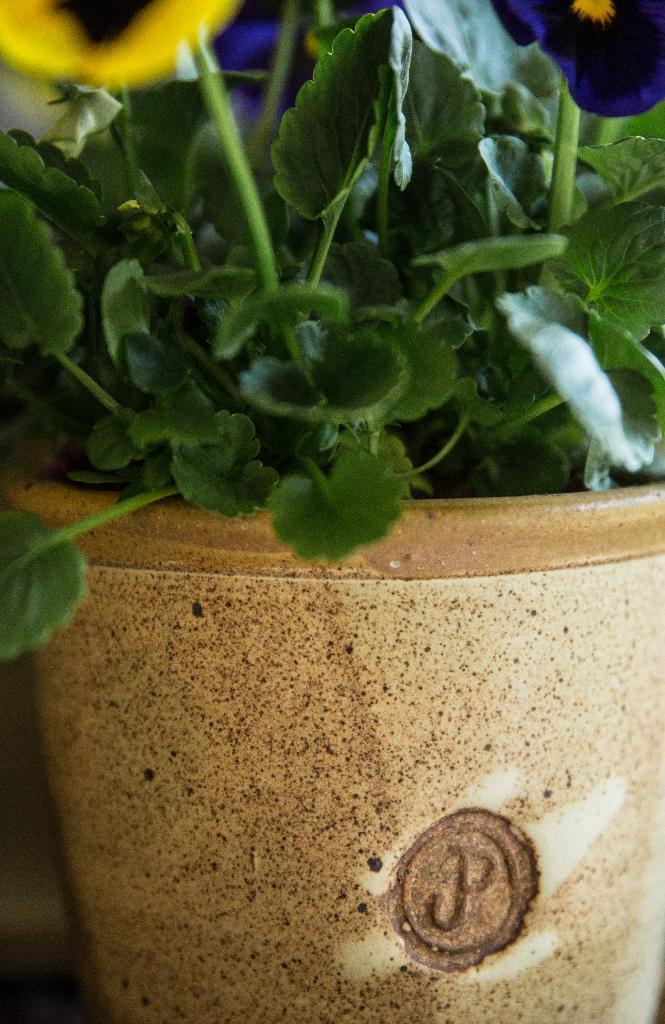Please provide a concise description of this image. In this picture there are yellow and dark blue flowers on the plant and there is a plant in the pot. 